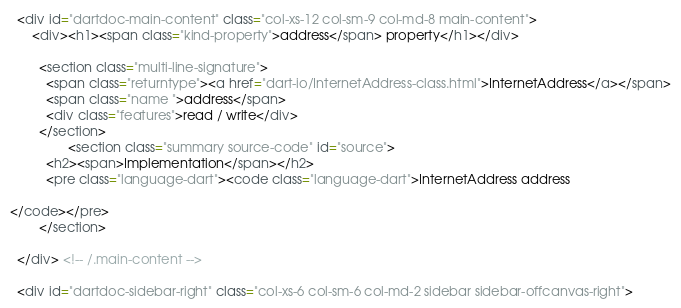Convert code to text. <code><loc_0><loc_0><loc_500><loc_500><_HTML_>
  <div id="dartdoc-main-content" class="col-xs-12 col-sm-9 col-md-8 main-content">
      <div><h1><span class="kind-property">address</span> property</h1></div>

        <section class="multi-line-signature">
          <span class="returntype"><a href="dart-io/InternetAddress-class.html">InternetAddress</a></span>
          <span class="name ">address</span>
          <div class="features">read / write</div>
        </section>
                <section class="summary source-code" id="source">
          <h2><span>Implementation</span></h2>
          <pre class="language-dart"><code class="language-dart">InternetAddress address

</code></pre>
        </section>

  </div> <!-- /.main-content -->

  <div id="dartdoc-sidebar-right" class="col-xs-6 col-sm-6 col-md-2 sidebar sidebar-offcanvas-right"></code> 